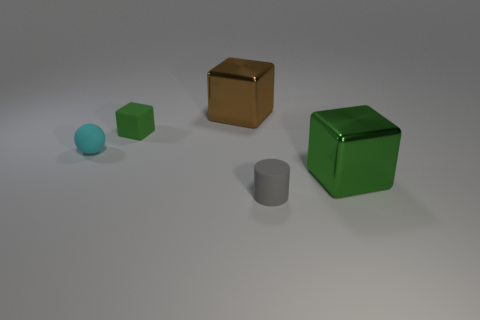What shape is the large metal object that is behind the cyan rubber object?
Offer a terse response. Cube. Are there any large shiny things that have the same color as the rubber cube?
Offer a terse response. Yes. Do the rubber block behind the tiny gray rubber object and the sphere behind the gray matte cylinder have the same size?
Offer a very short reply. Yes. Are there more tiny cylinders that are to the right of the brown metallic block than cylinders that are behind the tiny rubber sphere?
Give a very brief answer. Yes. Is there a small gray thing that has the same material as the small sphere?
Offer a very short reply. Yes. There is a thing that is both on the left side of the large green cube and right of the large brown cube; what material is it?
Offer a very short reply. Rubber. What color is the rubber cylinder?
Ensure brevity in your answer.  Gray. What number of large brown things are the same shape as the large green thing?
Offer a very short reply. 1. Is the material of the cube in front of the small matte ball the same as the green object left of the rubber cylinder?
Give a very brief answer. No. There is a cube in front of the matte block that is to the left of the cylinder; what is its size?
Offer a very short reply. Large. 